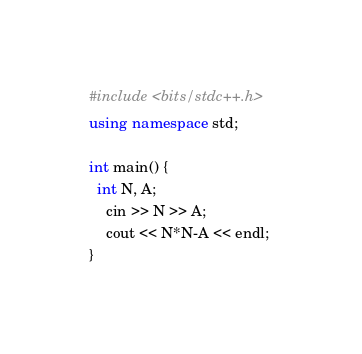Convert code to text. <code><loc_0><loc_0><loc_500><loc_500><_C++_>#include <bits/stdc++.h>
using namespace std;

int main() {
  int N, A;
    cin >> N >> A;
    cout << N*N-A << endl; 
}</code> 